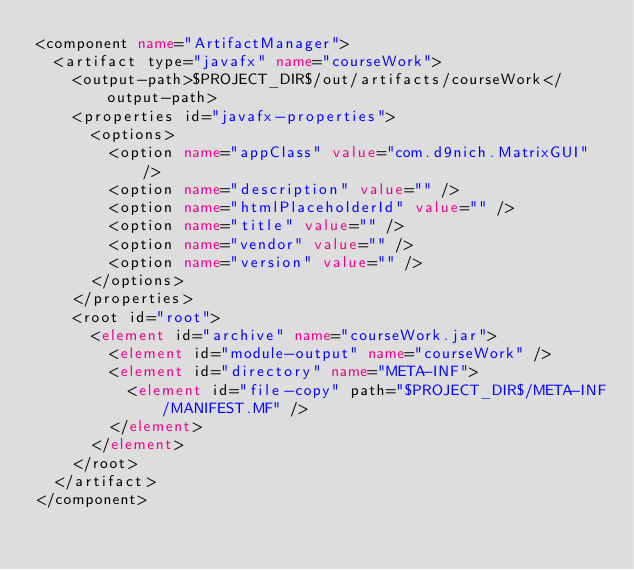Convert code to text. <code><loc_0><loc_0><loc_500><loc_500><_XML_><component name="ArtifactManager">
  <artifact type="javafx" name="courseWork">
    <output-path>$PROJECT_DIR$/out/artifacts/courseWork</output-path>
    <properties id="javafx-properties">
      <options>
        <option name="appClass" value="com.d9nich.MatrixGUI" />
        <option name="description" value="" />
        <option name="htmlPlaceholderId" value="" />
        <option name="title" value="" />
        <option name="vendor" value="" />
        <option name="version" value="" />
      </options>
    </properties>
    <root id="root">
      <element id="archive" name="courseWork.jar">
        <element id="module-output" name="courseWork" />
        <element id="directory" name="META-INF">
          <element id="file-copy" path="$PROJECT_DIR$/META-INF/MANIFEST.MF" />
        </element>
      </element>
    </root>
  </artifact>
</component></code> 